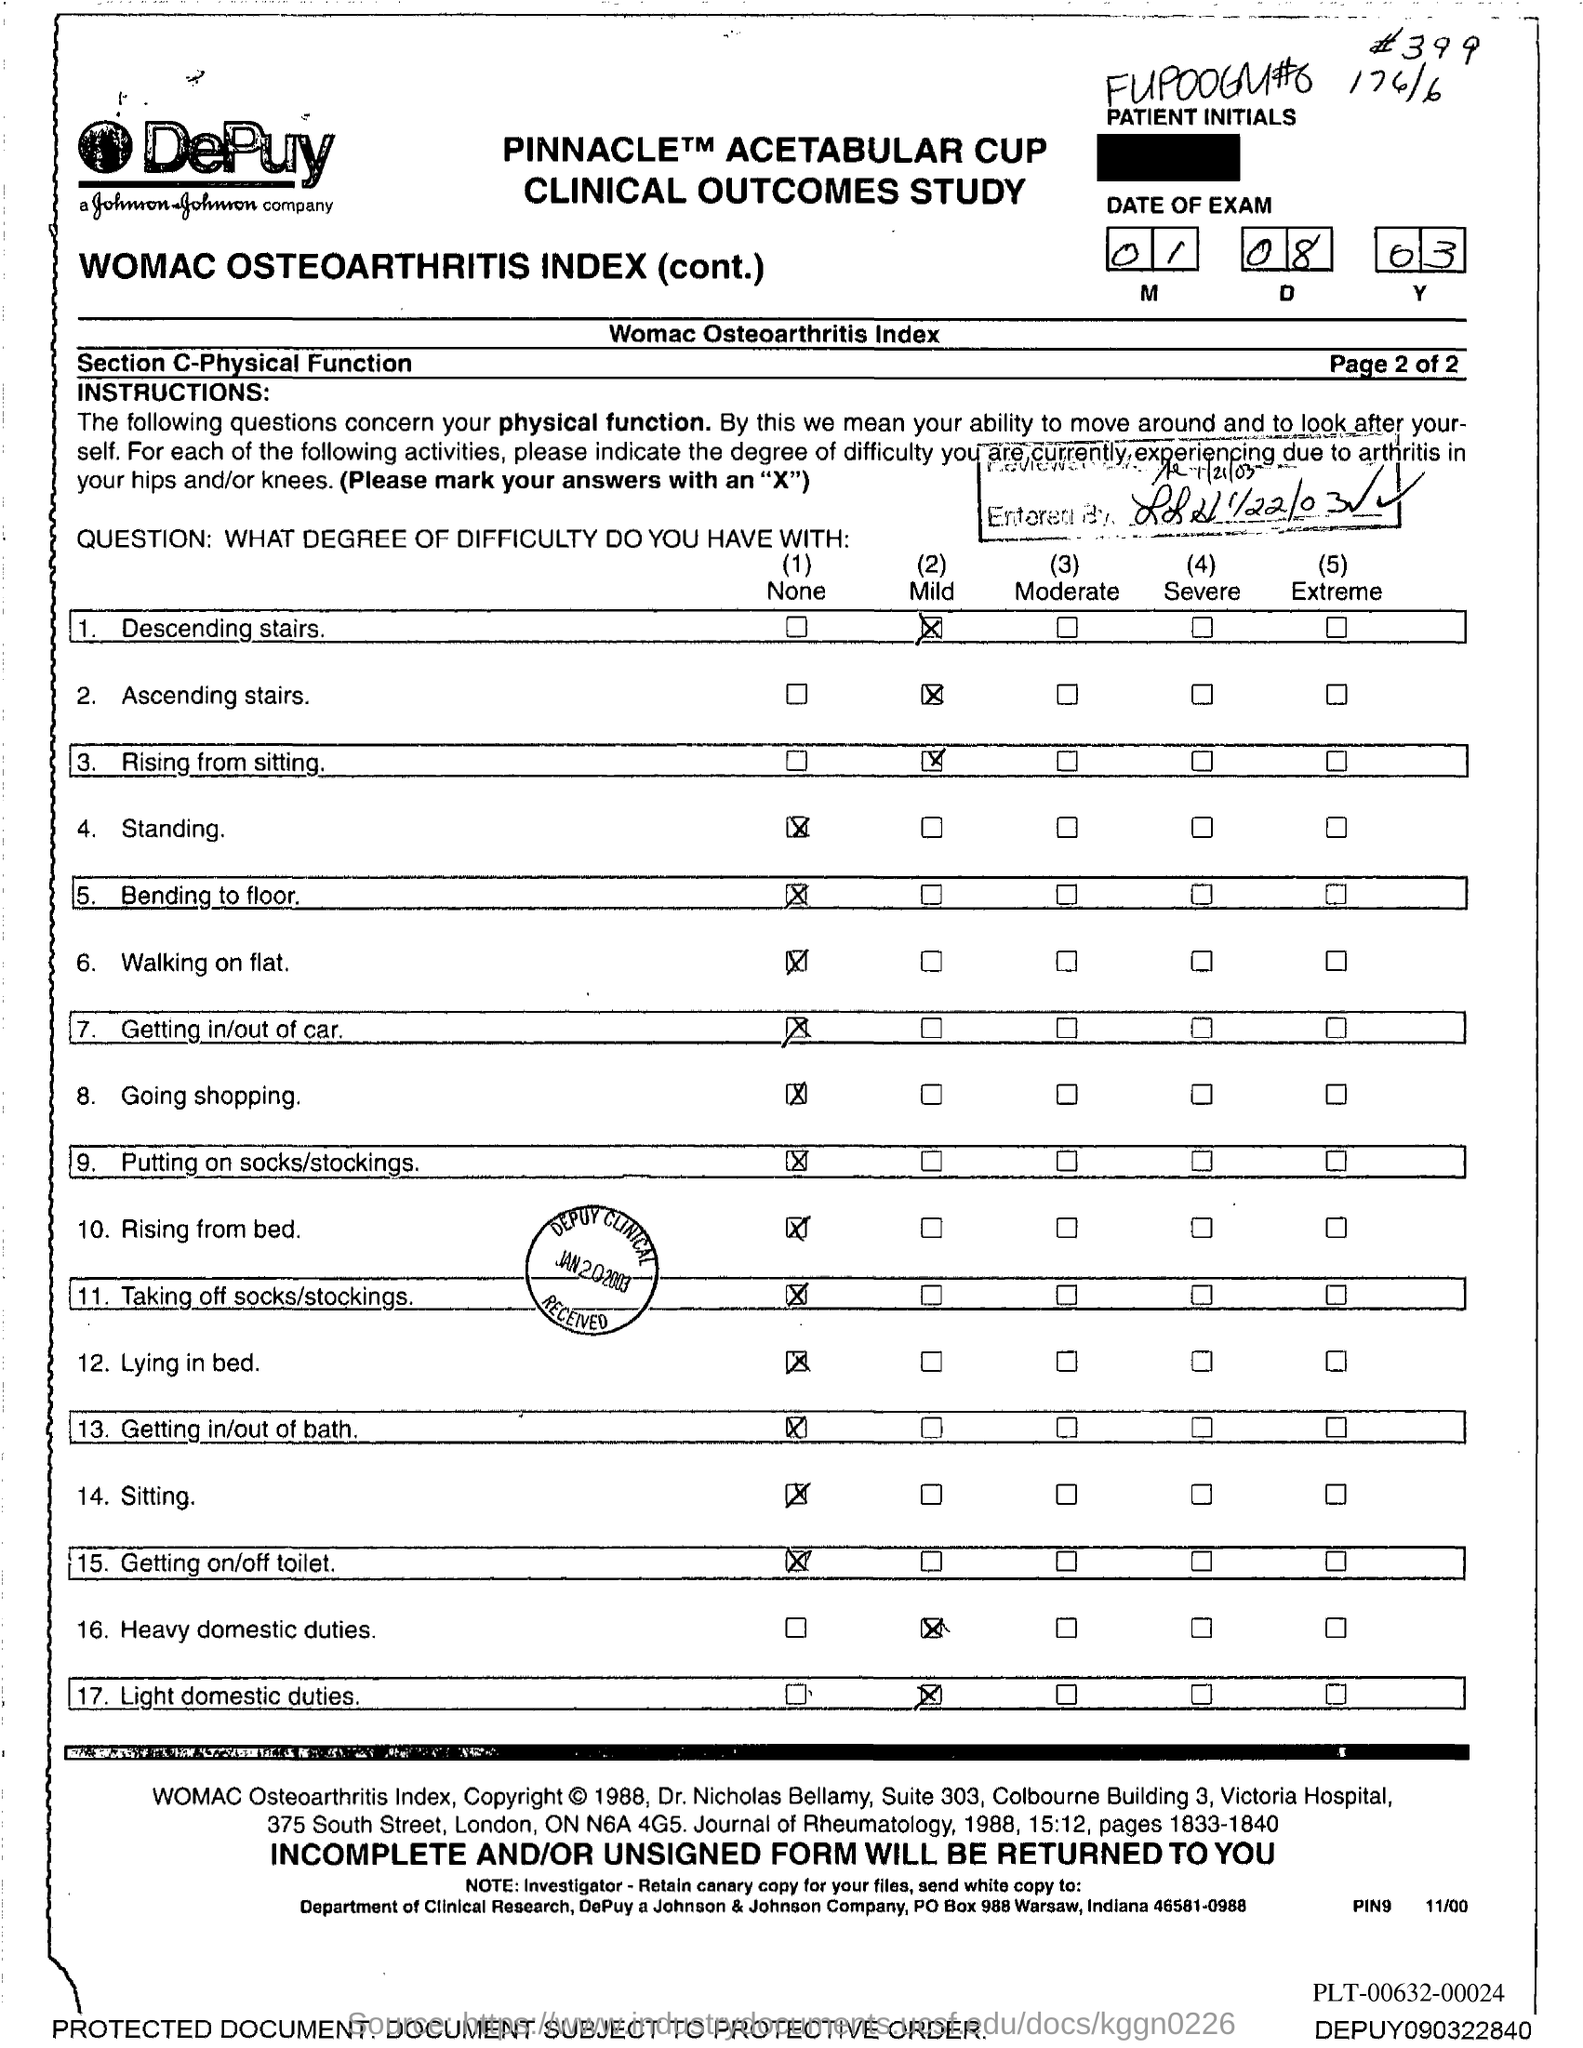What is the month of exam mentioned in the document?
Give a very brief answer. 01 08 03. 